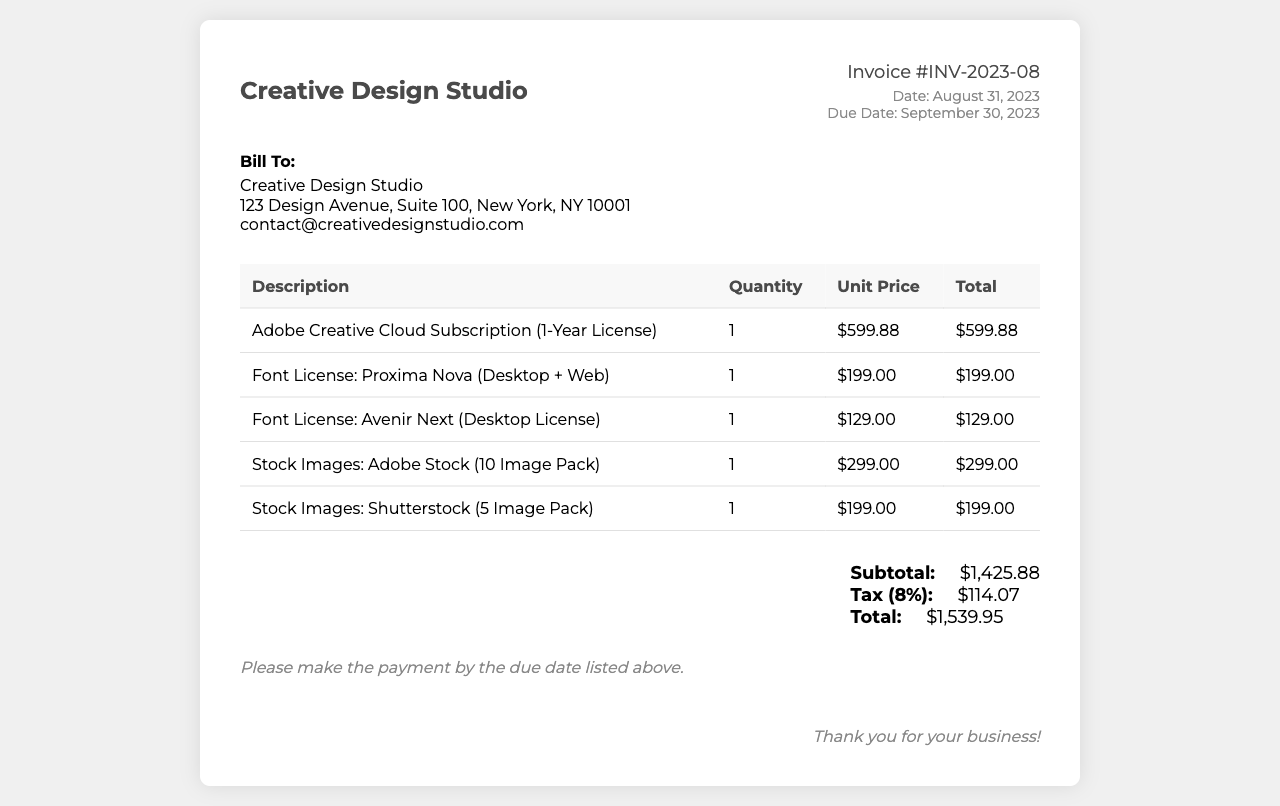What is the invoice number? The invoice number is located near the top of the document, identifying this specific transaction.
Answer: INV-2023-08 What is the due date for payment? The due date is mentioned under the invoice details, indicating by when the payment should be made.
Answer: September 30, 2023 What is the subtotal amount before tax? The subtotal is calculated from all line items before applying any tax, and it is listed in the total section.
Answer: $1,425.88 How many stock images were purchased from Shutterstock? The number of stock images is stated in the description of the corresponding line item on the invoice.
Answer: 5 What is the total amount due? The total amount due is calculated after adding tax to the subtotal and is displayed in the total section of the invoice.
Answer: $1,539.95 What is the tax rate applied to the invoice? The tax rate is provided in the total section, detailing the percentage applied to the subtotal.
Answer: 8% Where should the payment be sent? The payment instructions or destination may typically be included in the terms but are not explicitly stated here.
Answer: (not provided) What is the license type for Proxima Nova font? The license type is mentioned in the item description for the font, indicating use cases or restrictions.
Answer: Desktop + Web Who is billed for this invoice? The billing information is presented at the top of the document, detailing the individual or company responsible for payment.
Answer: Creative Design Studio 